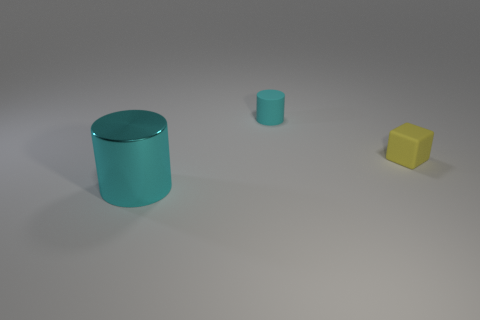What is the color of the small rubber cylinder?
Provide a short and direct response. Cyan. What number of things are large cyan cylinders or small gray cylinders?
Your answer should be compact. 1. Are there any other things that have the same material as the small yellow object?
Make the answer very short. Yes. Are there fewer yellow blocks that are in front of the small yellow rubber cube than cyan matte objects?
Give a very brief answer. Yes. Is the number of big things in front of the rubber block greater than the number of big cyan metal cylinders that are behind the cyan rubber thing?
Give a very brief answer. Yes. Is there anything else that is the same color as the metal cylinder?
Ensure brevity in your answer.  Yes. There is a object that is behind the small yellow rubber cube; what is it made of?
Give a very brief answer. Rubber. Do the cyan matte object and the metal object have the same size?
Give a very brief answer. No. What number of other objects are the same size as the yellow rubber cube?
Offer a very short reply. 1. Does the matte cylinder have the same color as the rubber block?
Make the answer very short. No. 